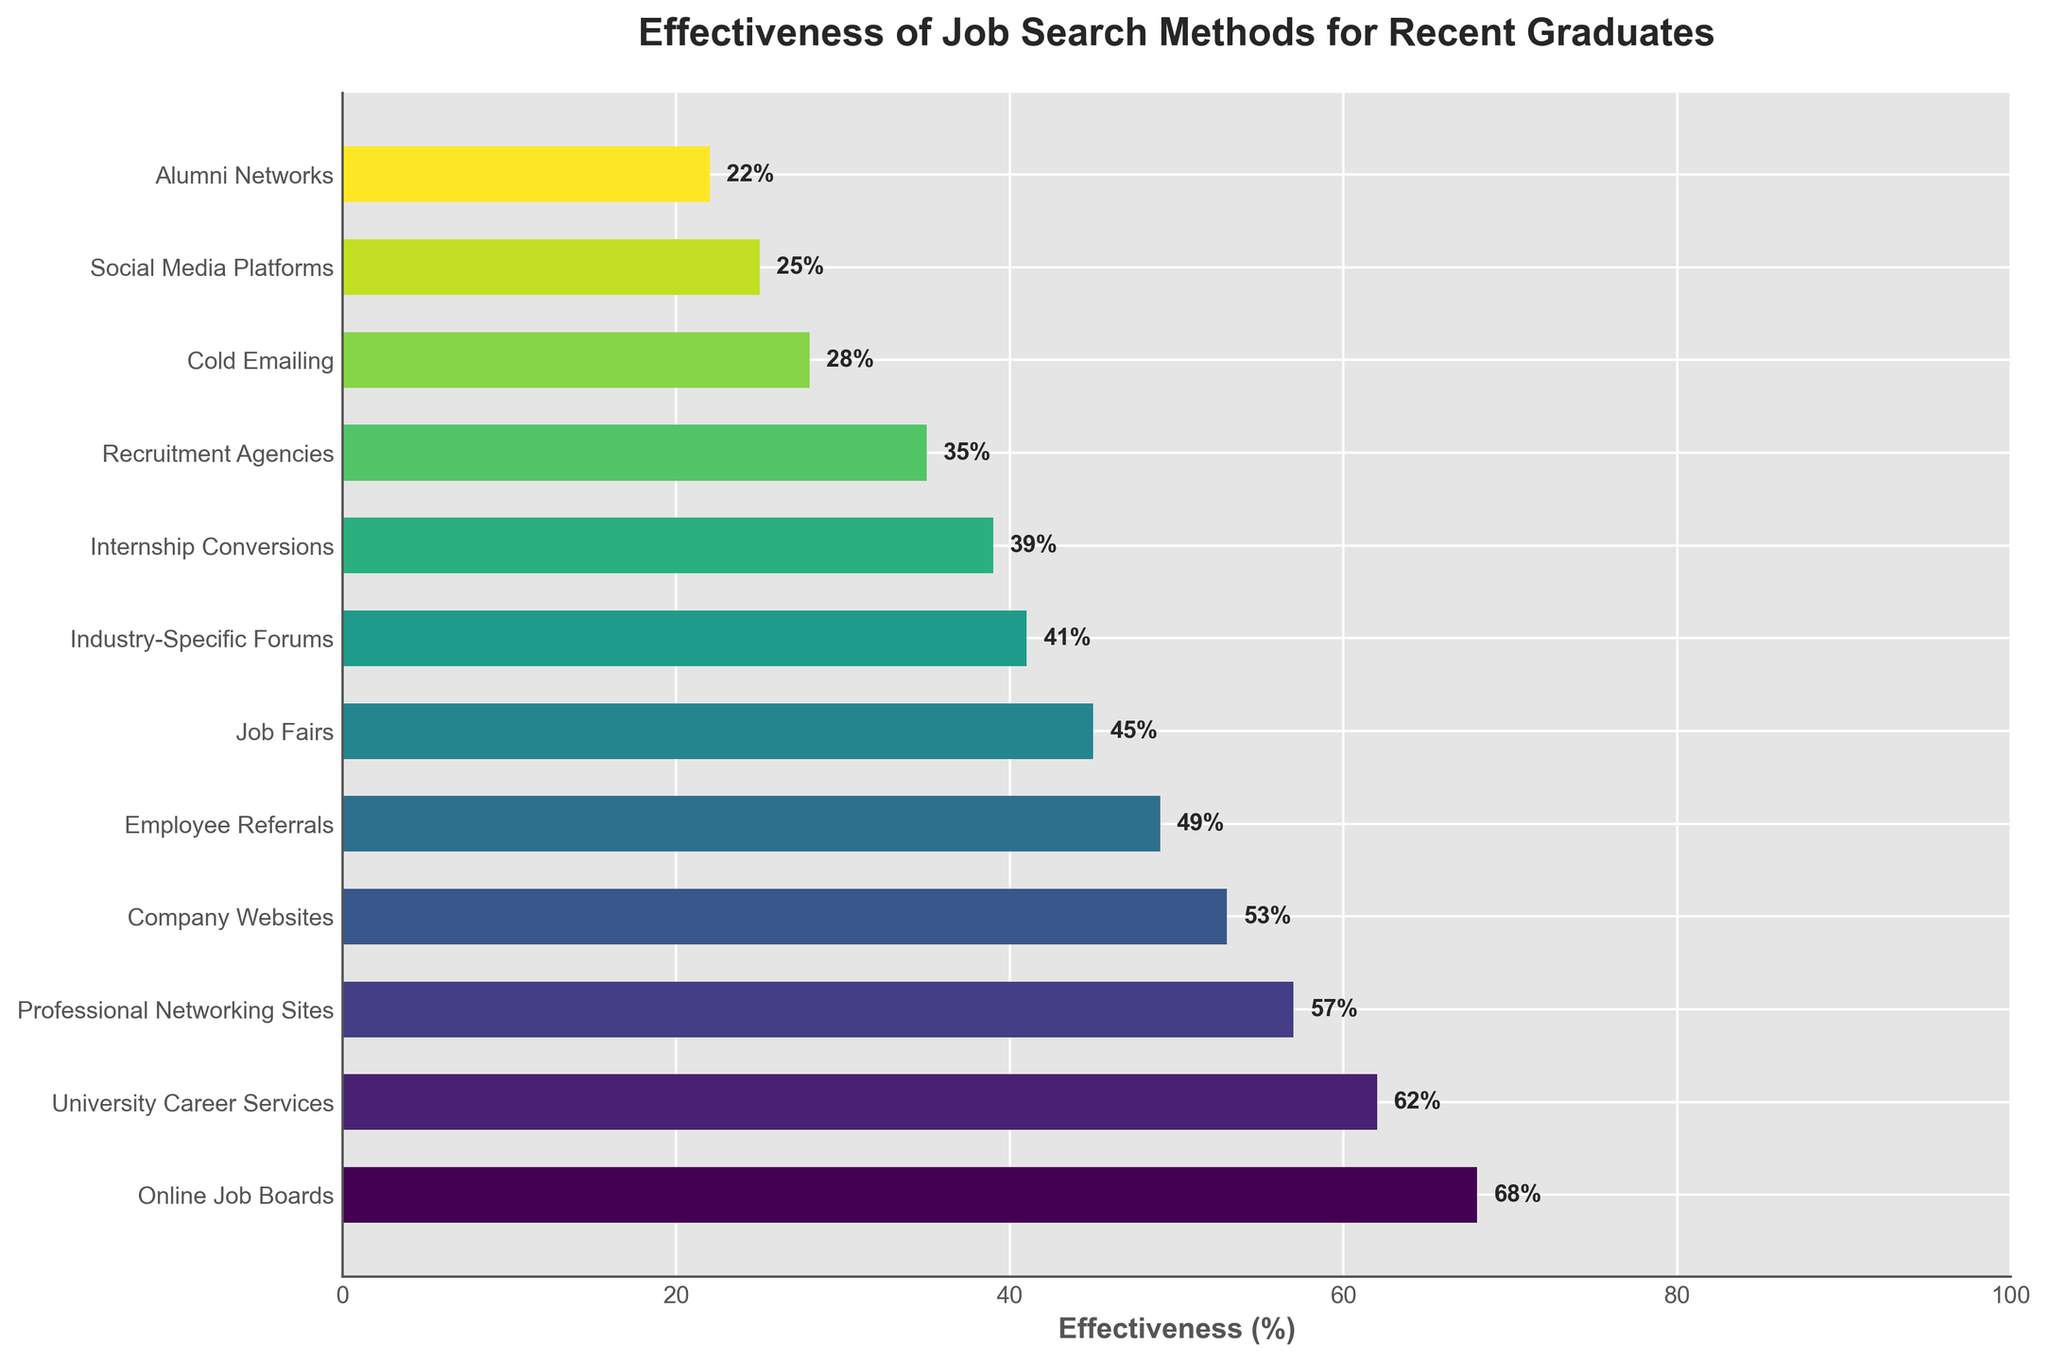What is the most effective job search method according to the figure? The method with the highest bar length corresponds to Online Job Boards, which also has the tallest bar visually indicating it as the most effective method.
Answer: Online Job Boards Which job search method has a higher effectiveness, University Career Services or Professional Networking Sites? By comparing the bar lengths, University Career Services has a longer bar than Professional Networking Sites.
Answer: University Career Services What is the difference in effectiveness between Company Websites and Job Fairs? The effectiveness of Company Websites is 53% and Job Fairs is 45%. The difference is calculated as 53% - 45%.
Answer: 8% Which job search methods have an effectiveness greater than 50%? Observing the bars that extend beyond the 50% mark, the methods are Online Job Boards, University Career Services, Professional Networking Sites, and Company Websites.
Answer: Online Job Boards, University Career Services, Professional Networking Sites, and Company Websites How much more effective are Online Job Boards compared to Cold Emailing? The effectiveness of Online Job Boards is 68%, and Cold Emailing is 28%. The difference is calculated as 68% - 28%.
Answer: 40% If we average the effectiveness of Social Media Platforms, Alumni Networks, and Internship Conversions, what is the result? Effectiveness for Social Media Platforms is 25%, Alumni Networks is 22%, and Internship Conversions is 39%. The average is calculated as (25% + 22% + 39%) / 3.
Answer: 28.67% Among Employee Referrals, Job Fairs, and Internship Conversions, which method has the lowest effectiveness? By comparing the bar lengths of these three methods, Internship Conversions has the shortest bar, indicating the lowest effectiveness.
Answer: Internship Conversions How many methods have an effectiveness of below 30%? Counting the number of bars that fall below the 30% mark, the methods are Cold Emailing, Social Media Platforms, and Alumni Networks.
Answer: 3 